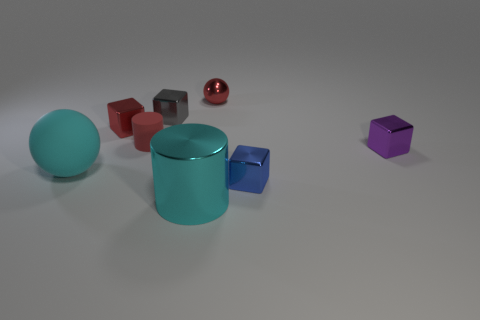Subtract all tiny blue cubes. How many cubes are left? 3 Subtract all cyan balls. How many balls are left? 1 Add 1 large green matte balls. How many objects exist? 9 Subtract 2 blocks. How many blocks are left? 2 Subtract all green blocks. Subtract all blue spheres. How many blocks are left? 4 Subtract all red spheres. How many yellow cylinders are left? 0 Subtract all big cyan metallic cylinders. Subtract all purple cubes. How many objects are left? 6 Add 5 red metal objects. How many red metal objects are left? 7 Add 7 tiny blue things. How many tiny blue things exist? 8 Subtract 1 red cylinders. How many objects are left? 7 